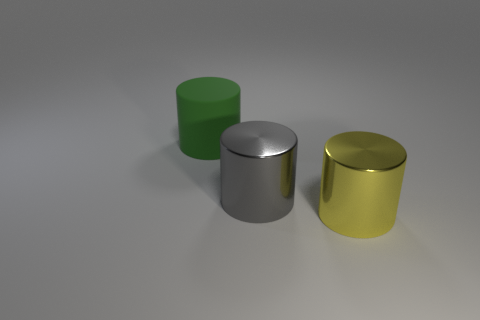Is there any other thing that is the same material as the large yellow cylinder?
Provide a short and direct response. Yes. What number of other things are there of the same shape as the big yellow thing?
Ensure brevity in your answer.  2. How many green matte objects are behind the cylinder that is in front of the metallic object that is on the left side of the big yellow metal object?
Offer a very short reply. 1. What number of tiny blue matte things are the same shape as the gray shiny thing?
Your response must be concise. 0. Do the big metal thing behind the yellow object and the matte cylinder have the same color?
Offer a very short reply. No. What shape is the large object that is behind the metallic cylinder that is behind the cylinder that is on the right side of the big gray object?
Provide a short and direct response. Cylinder. There is a rubber thing; does it have the same size as the metal cylinder in front of the gray object?
Ensure brevity in your answer.  Yes. Is there a cyan metal object that has the same size as the yellow shiny cylinder?
Keep it short and to the point. No. How many other things are there of the same material as the large yellow object?
Your answer should be compact. 1. There is a large cylinder that is behind the yellow metallic thing and on the right side of the big matte object; what color is it?
Your answer should be compact. Gray. 